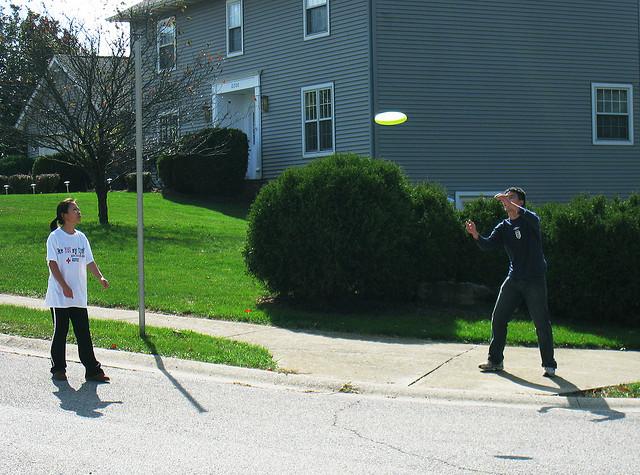Are there any flowers in the front yard?
Write a very short answer. No. Who is wearing jeans?
Write a very short answer. Man. Is the frisbee Pink?
Give a very brief answer. No. 